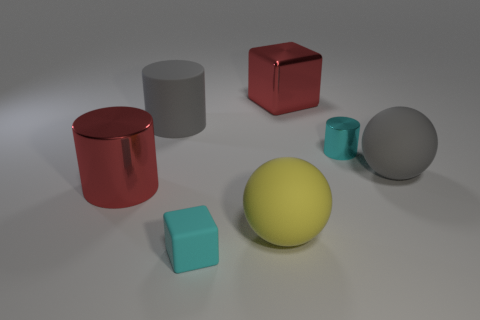There is a metal thing that is the same color as the big block; what is its shape?
Ensure brevity in your answer.  Cylinder. There is a big shiny thing that is in front of the big red shiny block; is its color the same as the metallic cube?
Offer a very short reply. Yes. There is a metal cylinder that is right of the big rubber cylinder behind the big yellow rubber object; how big is it?
Keep it short and to the point. Small. Is the number of big objects that are behind the large yellow ball greater than the number of spheres?
Your response must be concise. Yes. Is the size of the gray thing that is in front of the cyan metal object the same as the small cyan block?
Your response must be concise. No. There is a big object that is on the right side of the big shiny cylinder and in front of the large gray sphere; what color is it?
Provide a succinct answer. Yellow. What is the shape of the yellow rubber thing that is the same size as the gray sphere?
Provide a short and direct response. Sphere. Are there any other cylinders of the same color as the tiny metal cylinder?
Make the answer very short. No. Are there the same number of small cylinders that are left of the cyan block and large red cylinders?
Give a very brief answer. No. Do the small shiny cylinder and the tiny block have the same color?
Offer a terse response. Yes. 